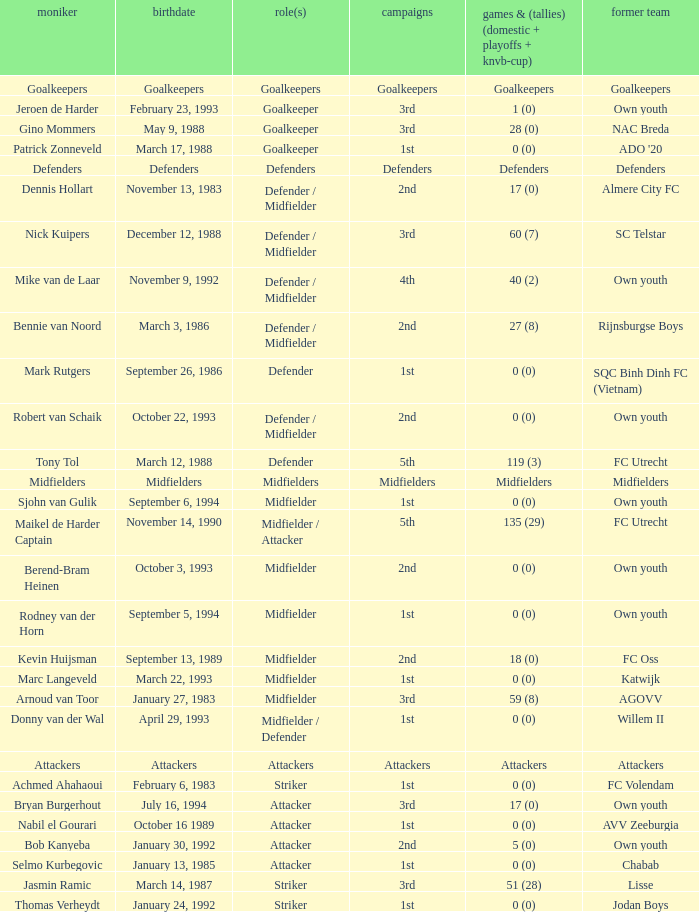What is the date of birth of the goalkeeper from the 1st season? March 17, 1988. 